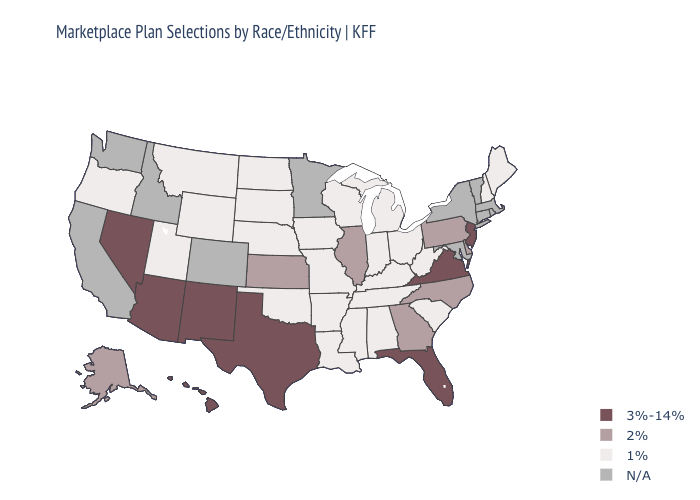What is the value of Kentucky?
Answer briefly. 1%. What is the value of California?
Give a very brief answer. N/A. Among the states that border Kentucky , does Indiana have the highest value?
Be succinct. No. Name the states that have a value in the range 1%?
Quick response, please. Alabama, Arkansas, Indiana, Iowa, Kentucky, Louisiana, Maine, Michigan, Mississippi, Missouri, Montana, Nebraska, New Hampshire, North Dakota, Ohio, Oklahoma, Oregon, South Carolina, South Dakota, Tennessee, Utah, West Virginia, Wisconsin, Wyoming. Which states have the lowest value in the USA?
Short answer required. Alabama, Arkansas, Indiana, Iowa, Kentucky, Louisiana, Maine, Michigan, Mississippi, Missouri, Montana, Nebraska, New Hampshire, North Dakota, Ohio, Oklahoma, Oregon, South Carolina, South Dakota, Tennessee, Utah, West Virginia, Wisconsin, Wyoming. Does the map have missing data?
Quick response, please. Yes. What is the lowest value in the Northeast?
Answer briefly. 1%. Name the states that have a value in the range 2%?
Quick response, please. Alaska, Delaware, Georgia, Illinois, Kansas, North Carolina, Pennsylvania. Which states have the lowest value in the USA?
Short answer required. Alabama, Arkansas, Indiana, Iowa, Kentucky, Louisiana, Maine, Michigan, Mississippi, Missouri, Montana, Nebraska, New Hampshire, North Dakota, Ohio, Oklahoma, Oregon, South Carolina, South Dakota, Tennessee, Utah, West Virginia, Wisconsin, Wyoming. Name the states that have a value in the range N/A?
Keep it brief. California, Colorado, Connecticut, Idaho, Maryland, Massachusetts, Minnesota, New York, Rhode Island, Vermont, Washington. Does Virginia have the lowest value in the USA?
Be succinct. No. Does Kansas have the lowest value in the USA?
Short answer required. No. Does Mississippi have the lowest value in the South?
Quick response, please. Yes. Among the states that border Florida , which have the highest value?
Quick response, please. Georgia. What is the value of Idaho?
Give a very brief answer. N/A. 